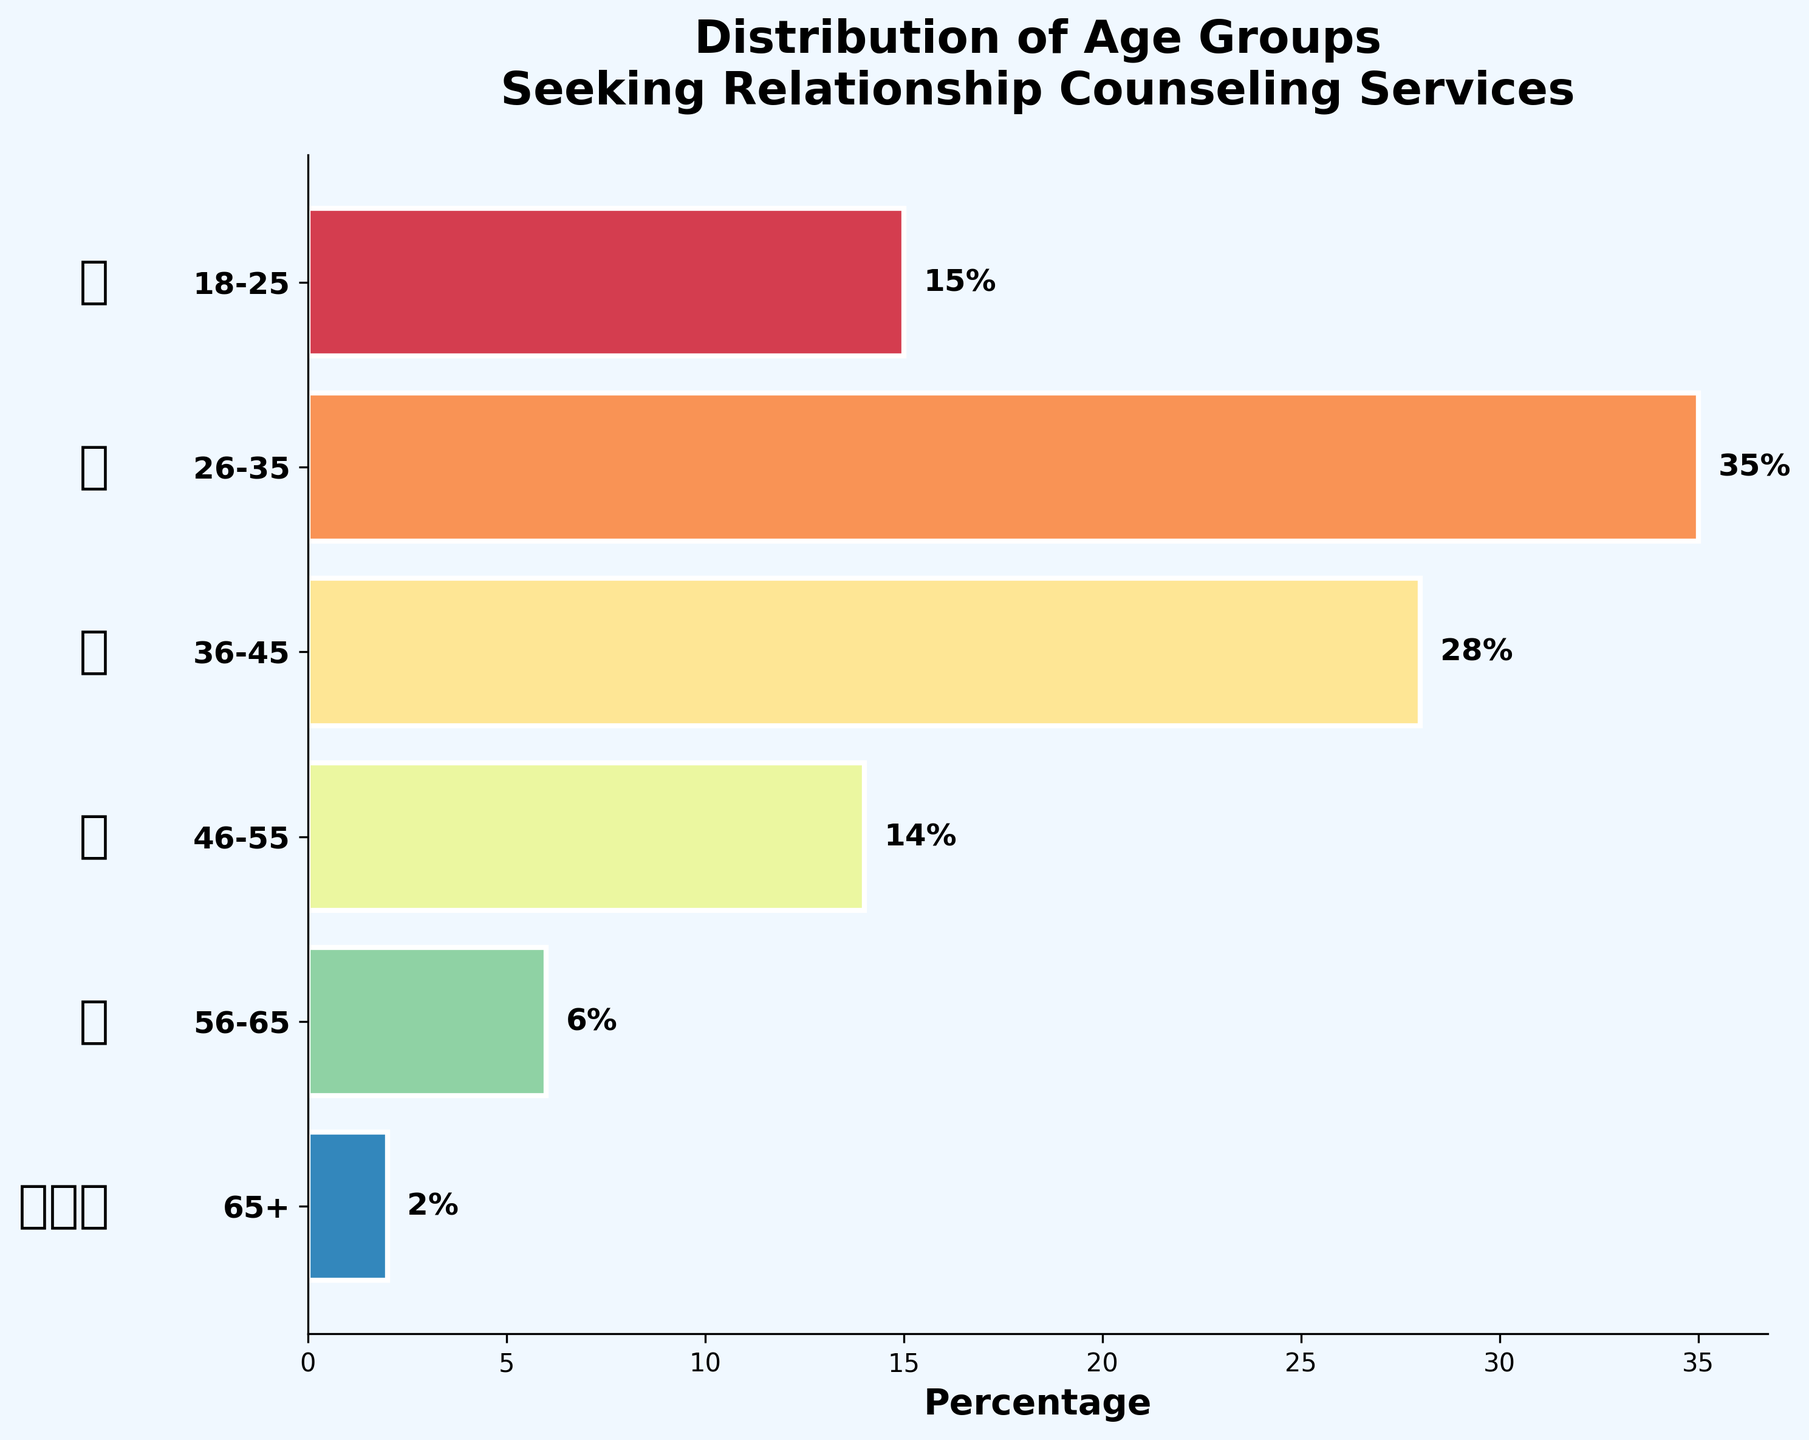What age group has the highest percentage of people seeking relationship counseling services? The bar for the age group 26-35 is the longest, reaching 35%.
Answer: 26-35 What is the percentage of people aged 18-25 seeking relationship counseling? The bar representing the age group 18-25 is labeled with 15%.
Answer: 15% What is the difference in percentage between the 36-45 and 46-55 age groups? The percentage for the 36-45 age group is 28%, and for the 46-55 age group, it is 14%. The difference is 28% - 14% = 14%.
Answer: 14% Which age group has the least number of people seeking relationship counseling services? The shortest bar, labeled with 2%, represents the 65+ age group.
Answer: 65+ What is the combined percentage of people seeking relationship counseling in the age groups 26-35 and 36-45? The percentage for the 26-35 group is 35%, and for the 36-45 group, it is 28%. Therefore, combined, it is 35% + 28% = 63%.
Answer: 63% How many age groups are represented in the funnel chart? The y-axis lists six age groups: 18-25, 26-35, 36-45, 46-55, 56-65, and 65+.
Answer: 6 Which age groups have a percentage below 10%? The age groups 56-65 and 65+ are labeled with percentages 6% and 2%, respectively, both of which are below 10%.
Answer: 56-65 and 65+ Based on the funnel chart, what age group shows a significant drop in percentage after the 36-45 group? The 36-45 age group has 28%, and the 46-55 age group has 14%, showing a significant drop of 14 percentage points.
Answer: 46-55 Are there more people aged 36-45 or 46-55 seeking relationship counseling services? The bar for the 36-45 age group is longer, labeled with 28%, compared to the 14% for the 46-55 age group.
Answer: 36-45 What visual icon represents the 26-35 age group in the funnel chart? The icon '💏' appears next to the 26-35 age group.
Answer: 💏 